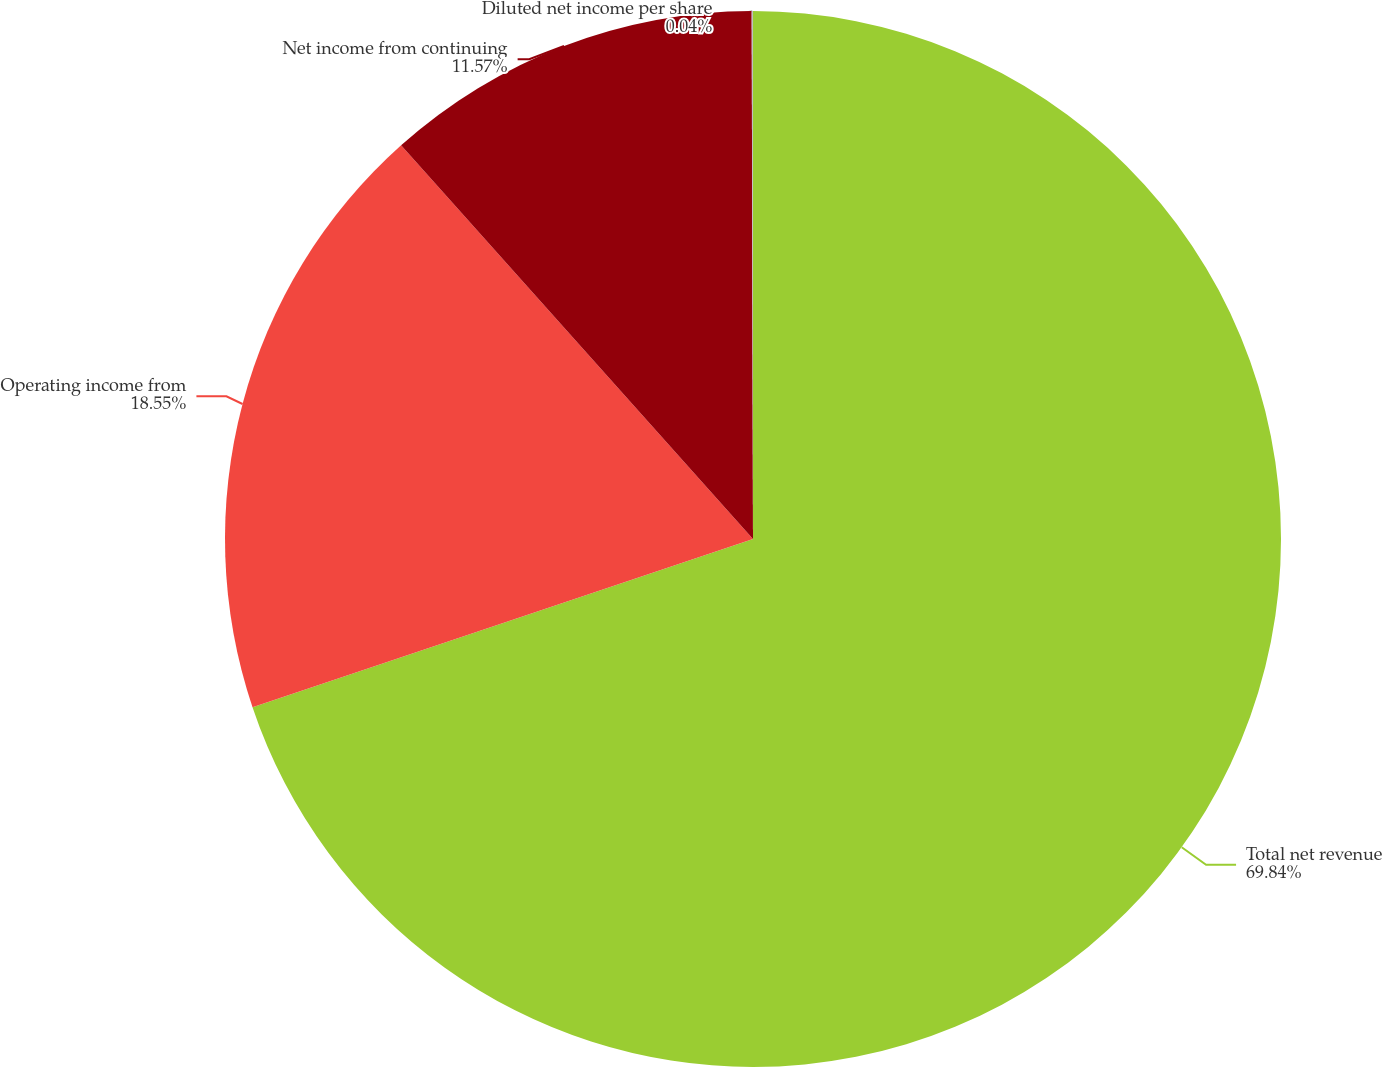<chart> <loc_0><loc_0><loc_500><loc_500><pie_chart><fcel>Total net revenue<fcel>Operating income from<fcel>Net income from continuing<fcel>Diluted net income per share<nl><fcel>69.84%<fcel>18.55%<fcel>11.57%<fcel>0.04%<nl></chart> 